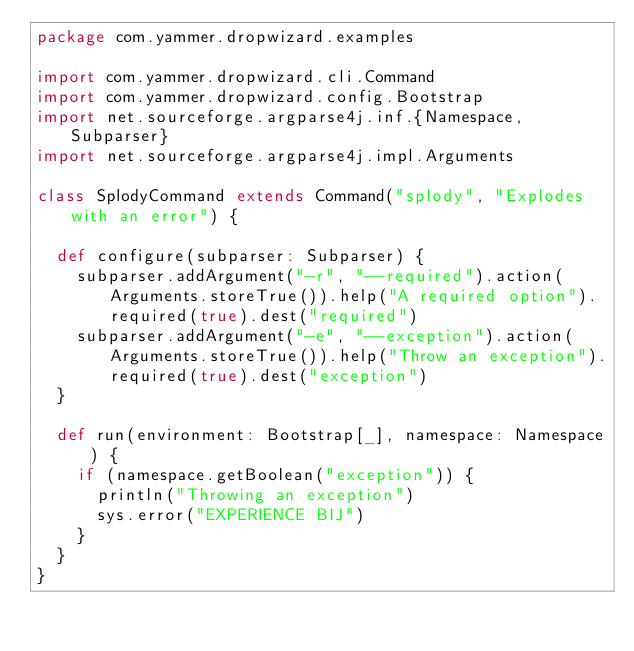<code> <loc_0><loc_0><loc_500><loc_500><_Scala_>package com.yammer.dropwizard.examples

import com.yammer.dropwizard.cli.Command
import com.yammer.dropwizard.config.Bootstrap
import net.sourceforge.argparse4j.inf.{Namespace, Subparser}
import net.sourceforge.argparse4j.impl.Arguments

class SplodyCommand extends Command("splody", "Explodes with an error") {

  def configure(subparser: Subparser) {
    subparser.addArgument("-r", "--required").action(Arguments.storeTrue()).help("A required option").required(true).dest("required")
    subparser.addArgument("-e", "--exception").action(Arguments.storeTrue()).help("Throw an exception").required(true).dest("exception")
  }

  def run(environment: Bootstrap[_], namespace: Namespace) {
    if (namespace.getBoolean("exception")) {
      println("Throwing an exception")
      sys.error("EXPERIENCE BIJ")
    }
  }
}
</code> 